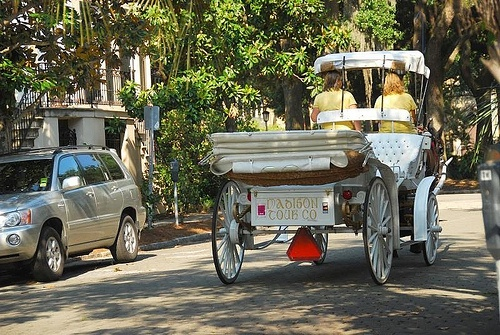Describe the objects in this image and their specific colors. I can see truck in darkgreen, black, gray, and darkgray tones, car in darkgreen, black, gray, and darkgray tones, people in darkgreen, ivory, khaki, black, and olive tones, parking meter in darkgreen, gray, darkgray, black, and purple tones, and people in darkgreen, khaki, tan, and olive tones in this image. 